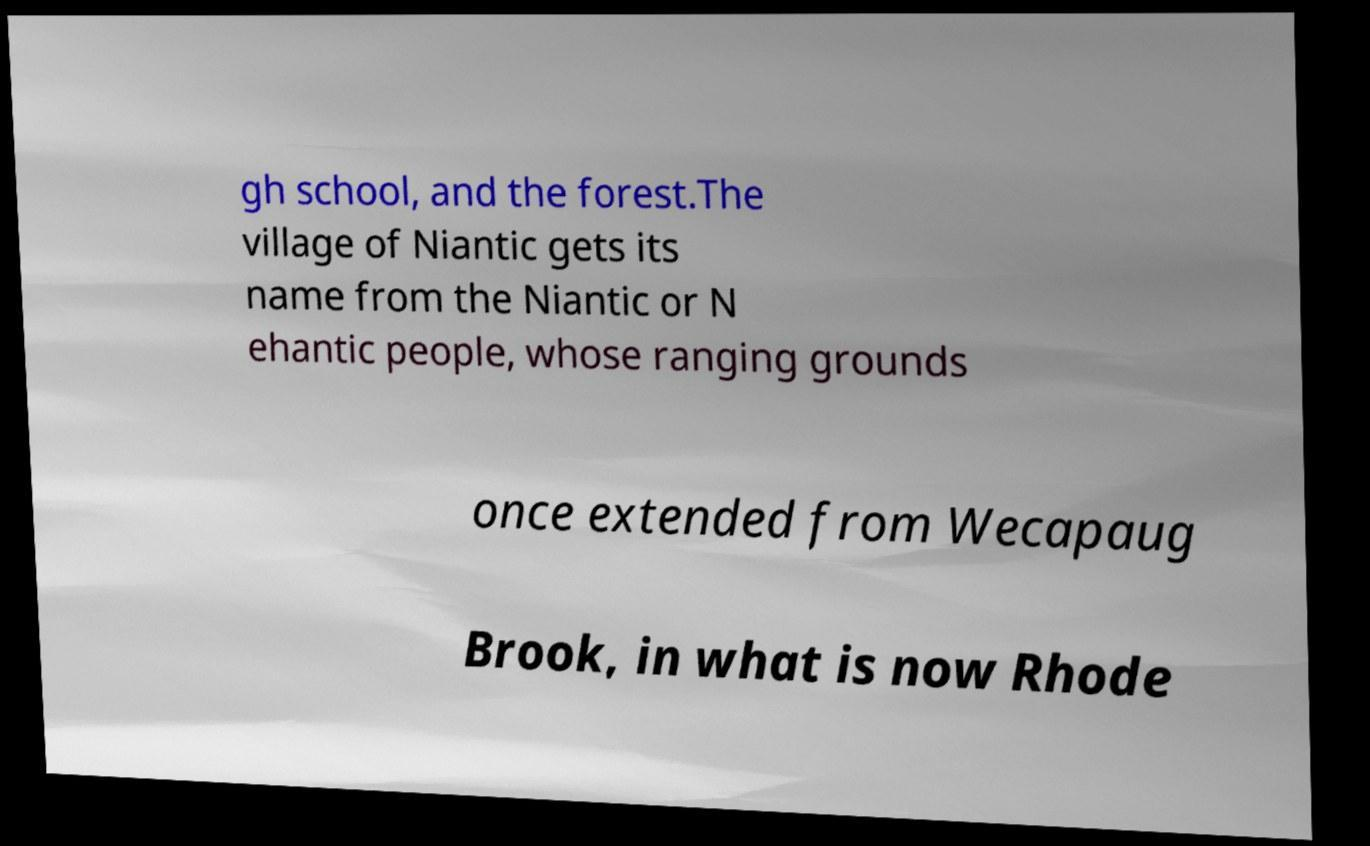Could you assist in decoding the text presented in this image and type it out clearly? gh school, and the forest.The village of Niantic gets its name from the Niantic or N ehantic people, whose ranging grounds once extended from Wecapaug Brook, in what is now Rhode 